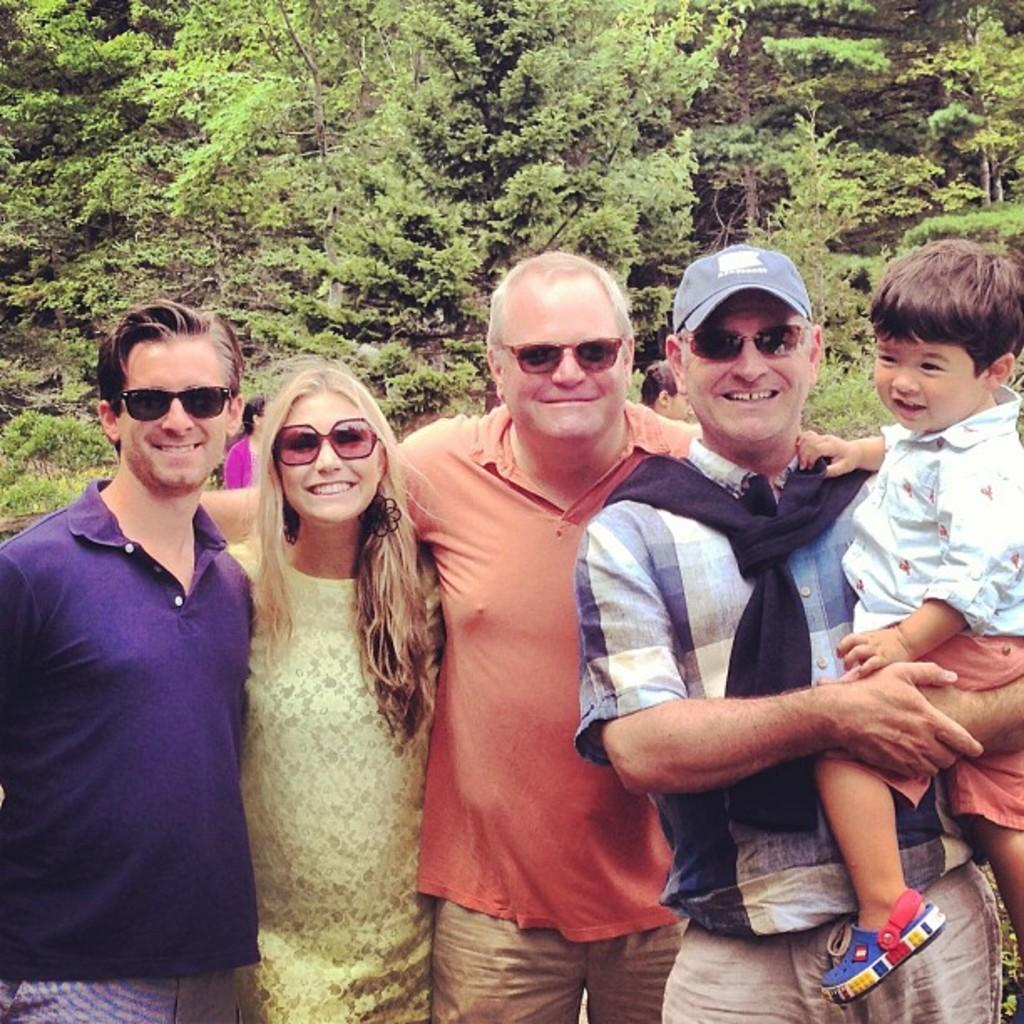How many people are in the group visible in the image? There is a group of people in the image, but the exact number is not specified. What are the people in the group doing in the image? The people are standing in the image. What expressions do the people in the group have? The people are smiling in the image. What can be seen in the background of the image? There are green color trees in the background of the image. What type of spark can be seen coming from the people's hands in the image? There is no spark visible in the image; the people are simply standing and smiling. What type of competition are the people participating in in the image? There is no competition visible in the image; the people are just standing and smiling. 